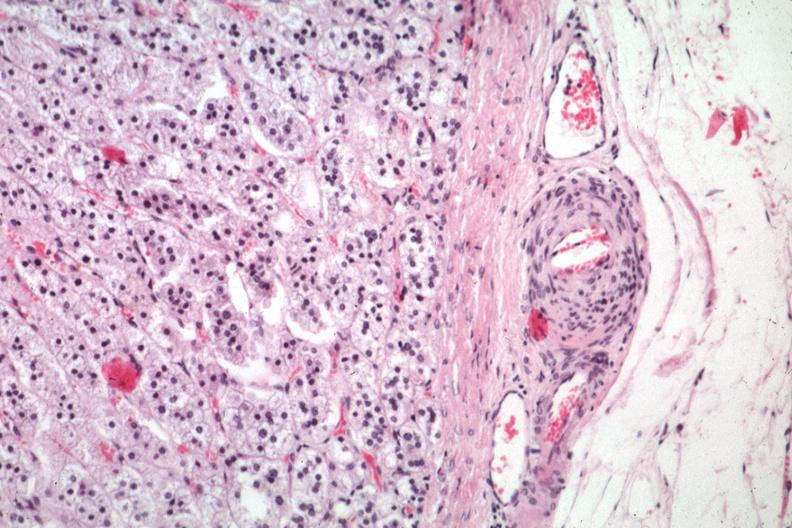s history present?
Answer the question using a single word or phrase. No 